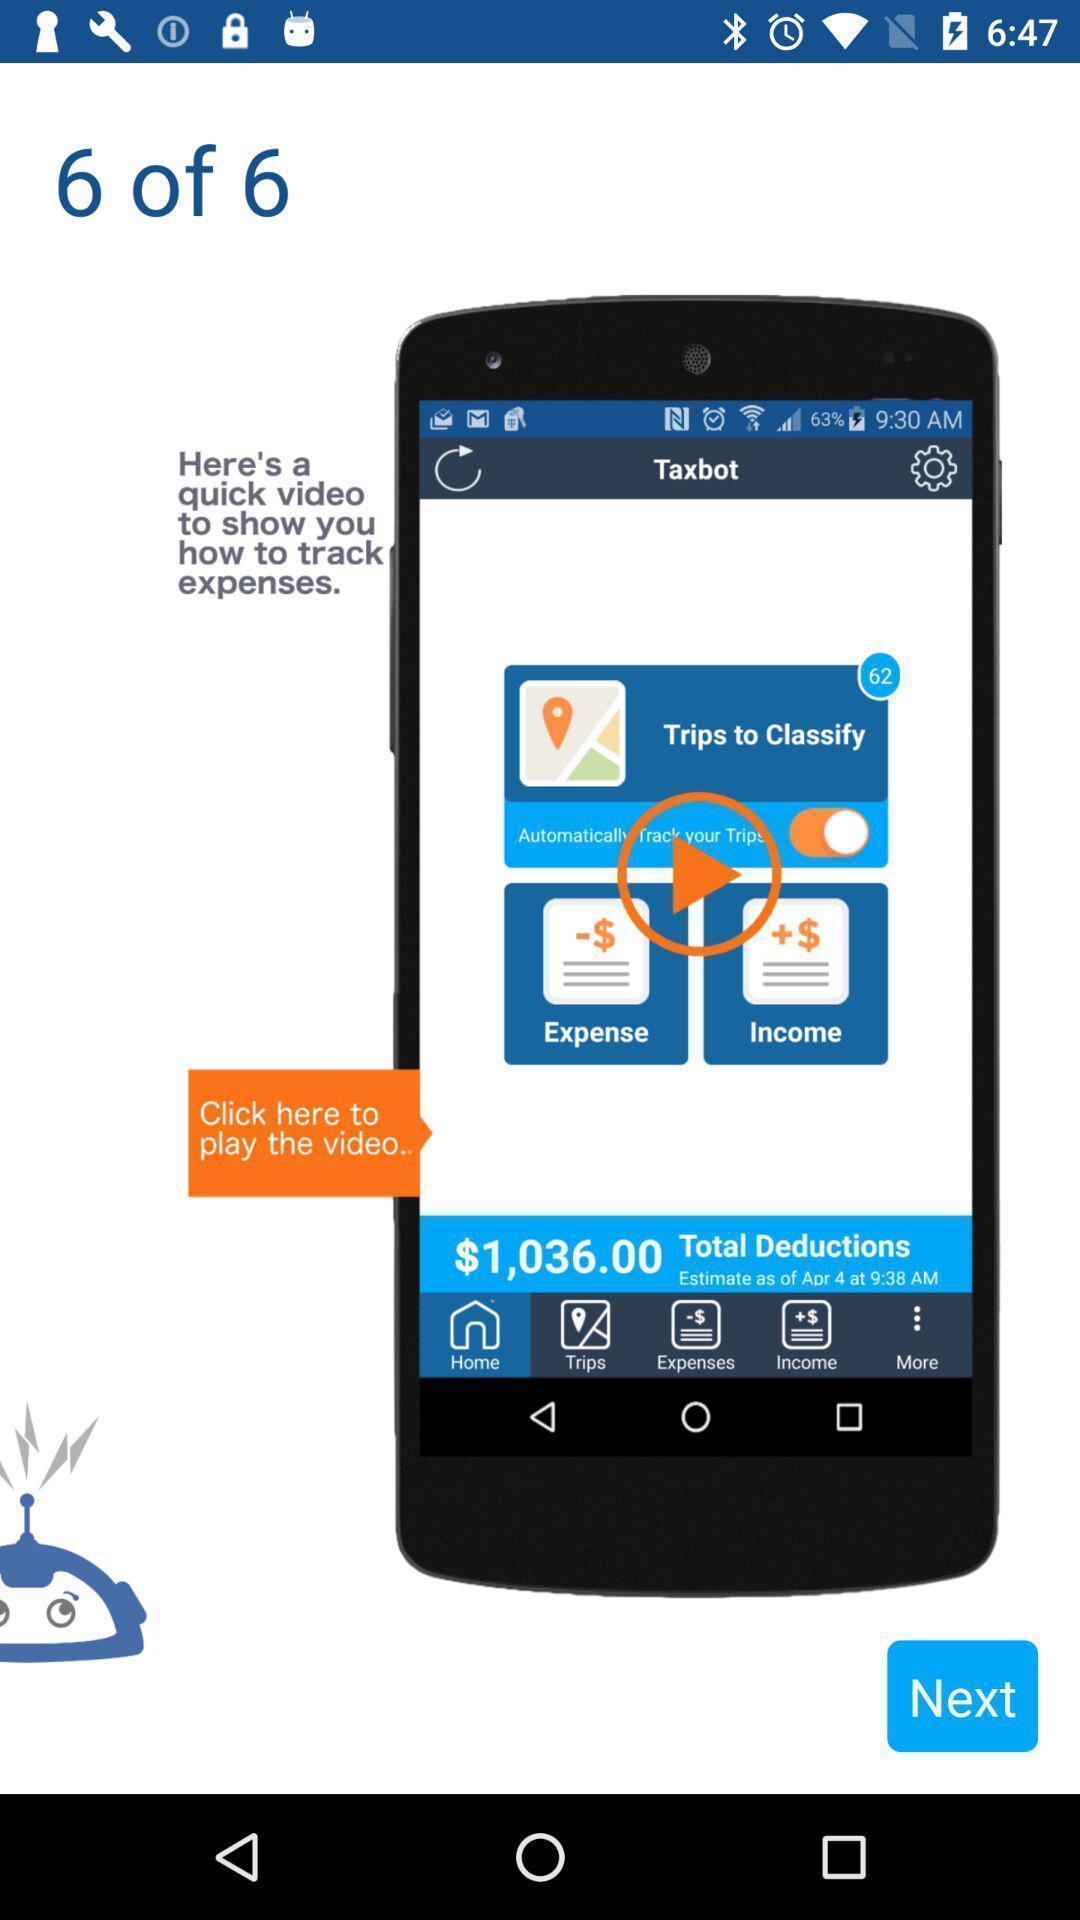What can you discern from this picture? Welcome screen. 